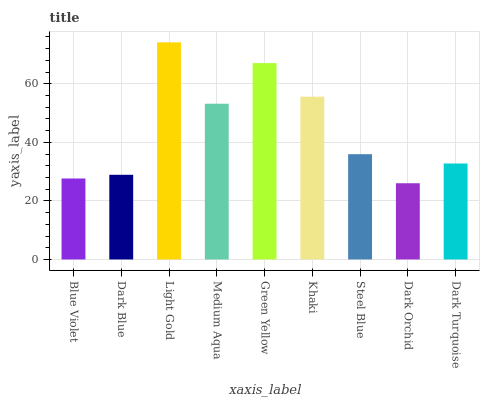Is Dark Orchid the minimum?
Answer yes or no. Yes. Is Light Gold the maximum?
Answer yes or no. Yes. Is Dark Blue the minimum?
Answer yes or no. No. Is Dark Blue the maximum?
Answer yes or no. No. Is Dark Blue greater than Blue Violet?
Answer yes or no. Yes. Is Blue Violet less than Dark Blue?
Answer yes or no. Yes. Is Blue Violet greater than Dark Blue?
Answer yes or no. No. Is Dark Blue less than Blue Violet?
Answer yes or no. No. Is Steel Blue the high median?
Answer yes or no. Yes. Is Steel Blue the low median?
Answer yes or no. Yes. Is Medium Aqua the high median?
Answer yes or no. No. Is Dark Blue the low median?
Answer yes or no. No. 